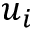<formula> <loc_0><loc_0><loc_500><loc_500>u _ { i }</formula> 